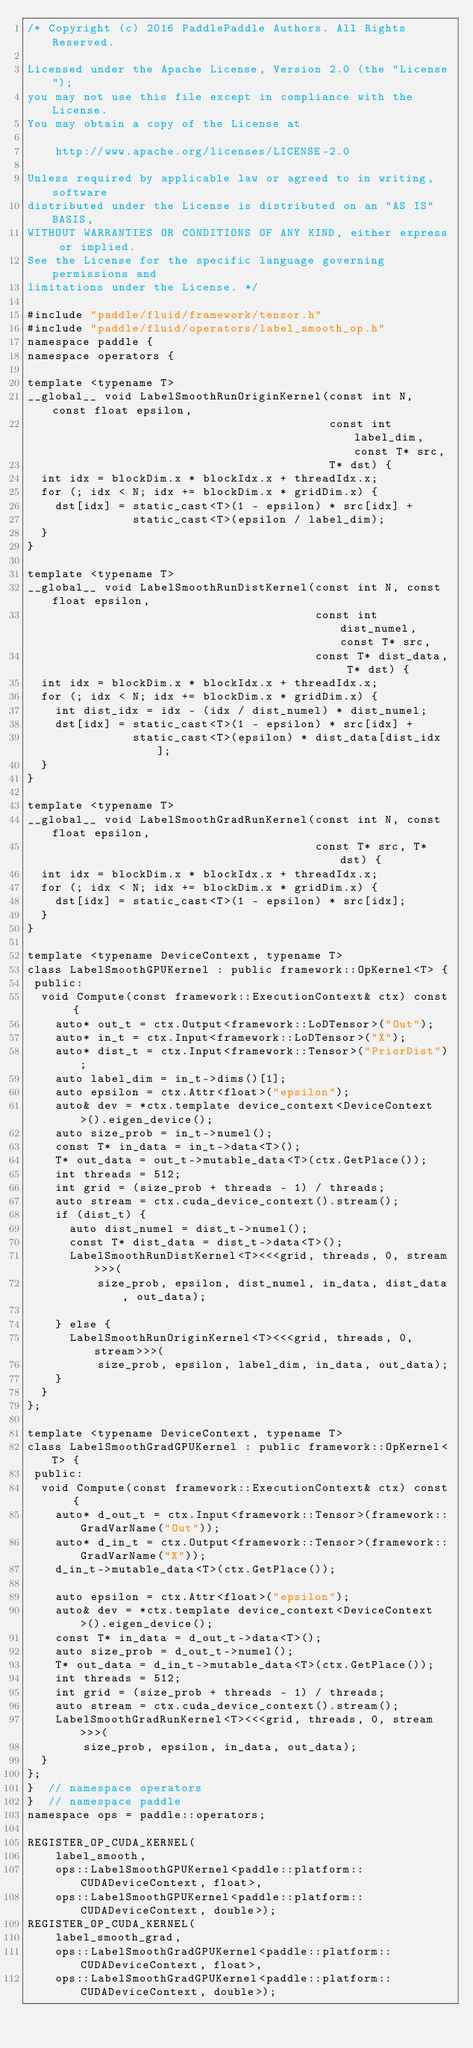Convert code to text. <code><loc_0><loc_0><loc_500><loc_500><_Cuda_>/* Copyright (c) 2016 PaddlePaddle Authors. All Rights Reserved.

Licensed under the Apache License, Version 2.0 (the "License");
you may not use this file except in compliance with the License.
You may obtain a copy of the License at

    http://www.apache.org/licenses/LICENSE-2.0

Unless required by applicable law or agreed to in writing, software
distributed under the License is distributed on an "AS IS" BASIS,
WITHOUT WARRANTIES OR CONDITIONS OF ANY KIND, either express or implied.
See the License for the specific language governing permissions and
limitations under the License. */

#include "paddle/fluid/framework/tensor.h"
#include "paddle/fluid/operators/label_smooth_op.h"
namespace paddle {
namespace operators {

template <typename T>
__global__ void LabelSmoothRunOriginKernel(const int N, const float epsilon,
                                           const int label_dim, const T* src,
                                           T* dst) {
  int idx = blockDim.x * blockIdx.x + threadIdx.x;
  for (; idx < N; idx += blockDim.x * gridDim.x) {
    dst[idx] = static_cast<T>(1 - epsilon) * src[idx] +
               static_cast<T>(epsilon / label_dim);
  }
}

template <typename T>
__global__ void LabelSmoothRunDistKernel(const int N, const float epsilon,
                                         const int dist_numel, const T* src,
                                         const T* dist_data, T* dst) {
  int idx = blockDim.x * blockIdx.x + threadIdx.x;
  for (; idx < N; idx += blockDim.x * gridDim.x) {
    int dist_idx = idx - (idx / dist_numel) * dist_numel;
    dst[idx] = static_cast<T>(1 - epsilon) * src[idx] +
               static_cast<T>(epsilon) * dist_data[dist_idx];
  }
}

template <typename T>
__global__ void LabelSmoothGradRunKernel(const int N, const float epsilon,
                                         const T* src, T* dst) {
  int idx = blockDim.x * blockIdx.x + threadIdx.x;
  for (; idx < N; idx += blockDim.x * gridDim.x) {
    dst[idx] = static_cast<T>(1 - epsilon) * src[idx];
  }
}

template <typename DeviceContext, typename T>
class LabelSmoothGPUKernel : public framework::OpKernel<T> {
 public:
  void Compute(const framework::ExecutionContext& ctx) const {
    auto* out_t = ctx.Output<framework::LoDTensor>("Out");
    auto* in_t = ctx.Input<framework::LoDTensor>("X");
    auto* dist_t = ctx.Input<framework::Tensor>("PriorDist");
    auto label_dim = in_t->dims()[1];
    auto epsilon = ctx.Attr<float>("epsilon");
    auto& dev = *ctx.template device_context<DeviceContext>().eigen_device();
    auto size_prob = in_t->numel();
    const T* in_data = in_t->data<T>();
    T* out_data = out_t->mutable_data<T>(ctx.GetPlace());
    int threads = 512;
    int grid = (size_prob + threads - 1) / threads;
    auto stream = ctx.cuda_device_context().stream();
    if (dist_t) {
      auto dist_numel = dist_t->numel();
      const T* dist_data = dist_t->data<T>();
      LabelSmoothRunDistKernel<T><<<grid, threads, 0, stream>>>(
          size_prob, epsilon, dist_numel, in_data, dist_data, out_data);

    } else {
      LabelSmoothRunOriginKernel<T><<<grid, threads, 0, stream>>>(
          size_prob, epsilon, label_dim, in_data, out_data);
    }
  }
};

template <typename DeviceContext, typename T>
class LabelSmoothGradGPUKernel : public framework::OpKernel<T> {
 public:
  void Compute(const framework::ExecutionContext& ctx) const {
    auto* d_out_t = ctx.Input<framework::Tensor>(framework::GradVarName("Out"));
    auto* d_in_t = ctx.Output<framework::Tensor>(framework::GradVarName("X"));
    d_in_t->mutable_data<T>(ctx.GetPlace());

    auto epsilon = ctx.Attr<float>("epsilon");
    auto& dev = *ctx.template device_context<DeviceContext>().eigen_device();
    const T* in_data = d_out_t->data<T>();
    auto size_prob = d_out_t->numel();
    T* out_data = d_in_t->mutable_data<T>(ctx.GetPlace());
    int threads = 512;
    int grid = (size_prob + threads - 1) / threads;
    auto stream = ctx.cuda_device_context().stream();
    LabelSmoothGradRunKernel<T><<<grid, threads, 0, stream>>>(
        size_prob, epsilon, in_data, out_data);
  }
};
}  // namespace operators
}  // namespace paddle
namespace ops = paddle::operators;

REGISTER_OP_CUDA_KERNEL(
    label_smooth,
    ops::LabelSmoothGPUKernel<paddle::platform::CUDADeviceContext, float>,
    ops::LabelSmoothGPUKernel<paddle::platform::CUDADeviceContext, double>);
REGISTER_OP_CUDA_KERNEL(
    label_smooth_grad,
    ops::LabelSmoothGradGPUKernel<paddle::platform::CUDADeviceContext, float>,
    ops::LabelSmoothGradGPUKernel<paddle::platform::CUDADeviceContext, double>);
</code> 